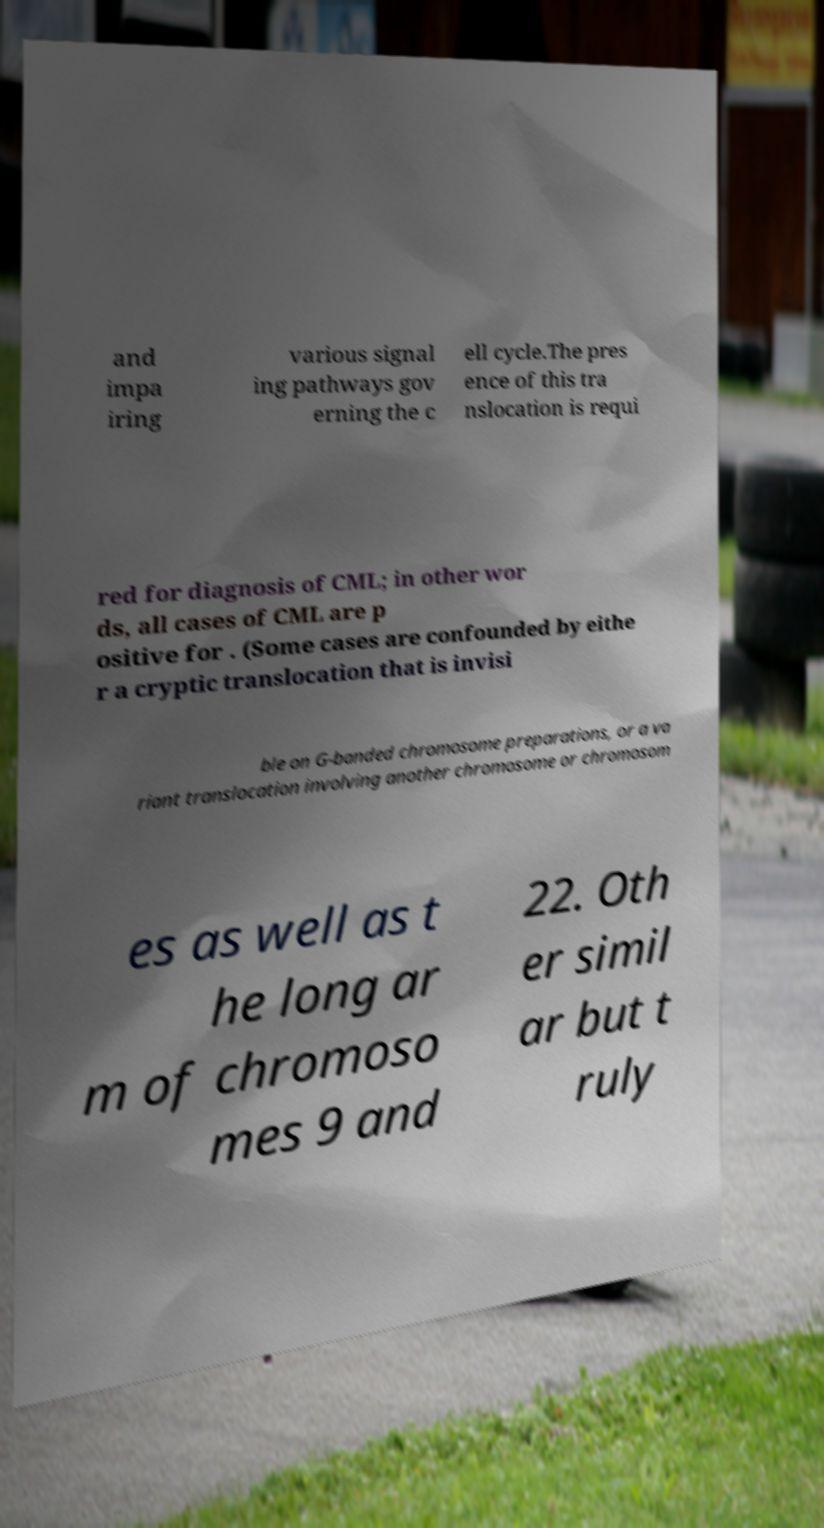Can you accurately transcribe the text from the provided image for me? and impa iring various signal ing pathways gov erning the c ell cycle.The pres ence of this tra nslocation is requi red for diagnosis of CML; in other wor ds, all cases of CML are p ositive for . (Some cases are confounded by eithe r a cryptic translocation that is invisi ble on G-banded chromosome preparations, or a va riant translocation involving another chromosome or chromosom es as well as t he long ar m of chromoso mes 9 and 22. Oth er simil ar but t ruly 